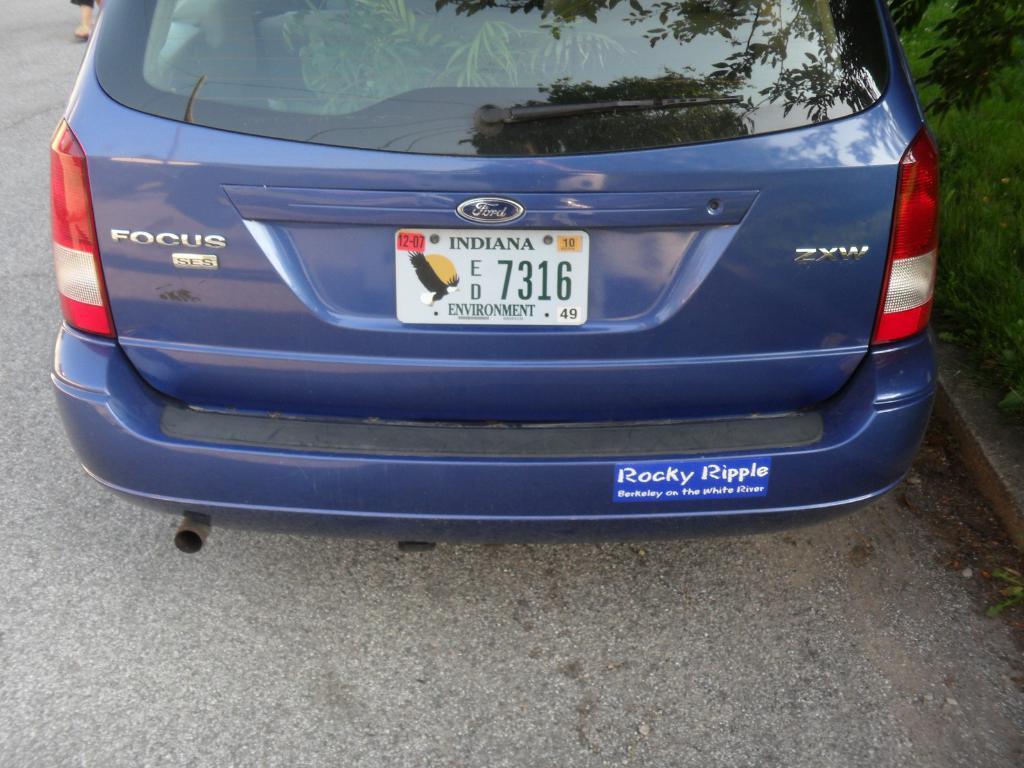Could you give a brief overview of what you see in this image? This picture is taken on the road. In this image, in the middle, we can see a car which is in blue color. On the right side, we can see some plants. On the left side, we can see the leg of a person. At the bottom, we can see a road. 